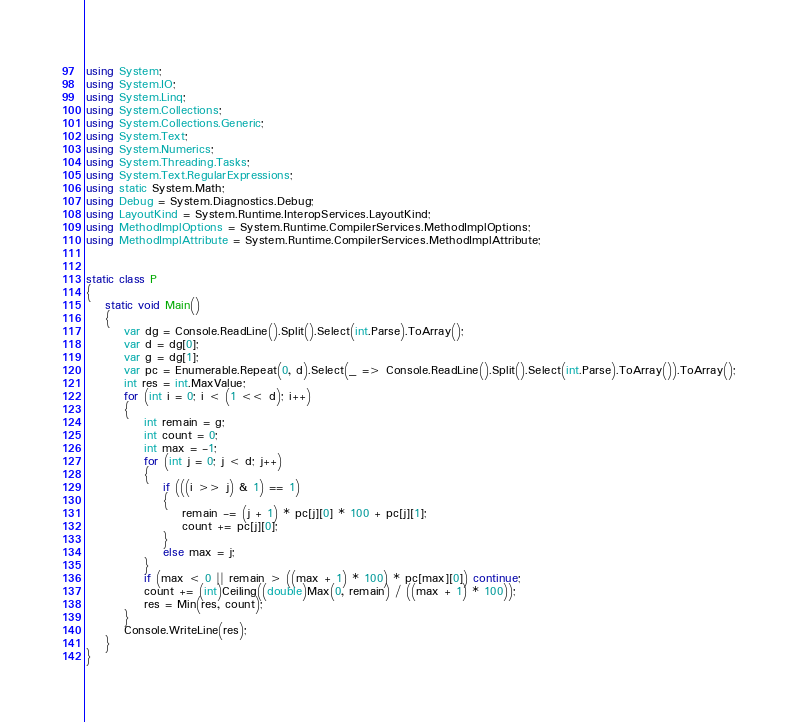<code> <loc_0><loc_0><loc_500><loc_500><_C#_>using System;
using System.IO;
using System.Linq;
using System.Collections;
using System.Collections.Generic;
using System.Text;
using System.Numerics;
using System.Threading.Tasks;
using System.Text.RegularExpressions;
using static System.Math;
using Debug = System.Diagnostics.Debug;
using LayoutKind = System.Runtime.InteropServices.LayoutKind;
using MethodImplOptions = System.Runtime.CompilerServices.MethodImplOptions;
using MethodImplAttribute = System.Runtime.CompilerServices.MethodImplAttribute;


static class P
{
    static void Main()
    {
        var dg = Console.ReadLine().Split().Select(int.Parse).ToArray();
        var d = dg[0];
        var g = dg[1];
        var pc = Enumerable.Repeat(0, d).Select(_ => Console.ReadLine().Split().Select(int.Parse).ToArray()).ToArray();
        int res = int.MaxValue;
        for (int i = 0; i < (1 << d); i++)
        {
            int remain = g;
            int count = 0;
            int max = -1;
            for (int j = 0; j < d; j++)
            {
                if (((i >> j) & 1) == 1)
                {
                    remain -= (j + 1) * pc[j][0] * 100 + pc[j][1];
                    count += pc[j][0];
                }
                else max = j;
            }
            if (max < 0 || remain > ((max + 1) * 100) * pc[max][0]) continue;
            count += (int)Ceiling((double)Max(0, remain) / ((max + 1) * 100));
            res = Min(res, count);
        }
        Console.WriteLine(res);
    }
}
</code> 